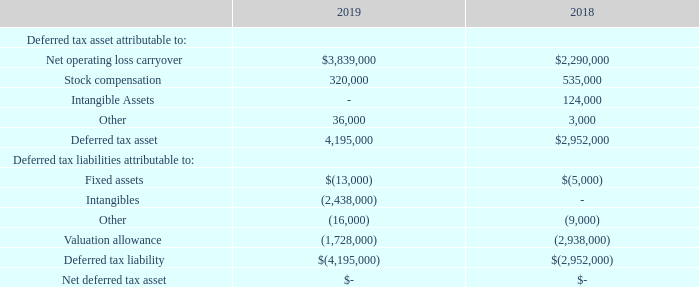NOTE 15 – INCOME TAXES (CONTINUED)
The cumulative tax effect of significant items comprising our net deferred tax amount at the expected rate of 21% is as follows as of December 31, 2019 and 2018:
The ultimate realization of deferred tax assets is dependent upon the Company’s ability to generate sufficient taxable income during the periods in which the net operating losses expire and the temporary differences become deductible. The Company has determined that there is significant uncertainty that the results of future operations and the reversals of existing taxable temporary differences will generate sufficient taxable income to realize the deferred tax assets; therefore, a valuation allowance has been recorded. In making this determination, the Company considered historical levels of income as well as projections for future periods.
The tax years 2016 to 2019 remain open for potential audit by the Internal Revenue Service. There are no uncertain tax positions as of December 31, 2018 or December 31, 2019, and none are expected in the next 12 months. The Company’s foreign subsidiaries are cost centers that are reimbursed for expenses, so generate no income or loss. Pretax book income (loss) is all from domestic operations. Up to four years of returns remain open for potential audit in foreign jurisdictions, however any audits for periods prior to ownership by the Company are the responsibility of the previous owners.
Under certain circumstances issuance of common shares can result in an ownership change under Internal Revenue Code Section 382, which limits the Company’s ability to utilize carry-forwards from prior to the ownership change. Any such ownership change resulting from stock issuances and redemptions could limit the Company’s ability to utilize any net operating loss carry-forwards or credits generated before this change in ownership. These limitations can limit both the timing of usage of these laws, as well as the loss of the ability to use these net operating losses. It is likely that fundraising activities have resulted in such an ownership change.
What is the ultimate realization of deferred tax assets dependent on? The company’s ability to generate sufficient taxable income during the periods in which the net operating losses expire and the temporary differences become deductible. Which tax years remain open for potential audit by the Internal Revenue Service? 2016 to 2019. How much are the deferred tax liabilities in 2018 and 2019, respectively? $(2,952,000), $(4,195,000). What is the percentage change in deferred tax assets in 2019 compared to 2018?
Answer scale should be: percent. (4,195,000-2,952,000)/2,952,000 
Answer: 42.11. What is the proportion of stock compensation and intangible assets over deferred tax assets in 2018? (535,000+124,000)/2,952,000 
Answer: 0.22. What is the average net operating loss carryover from 2018 to 2019? (3,839,000+2,290,000)/2 
Answer: 3064500. 